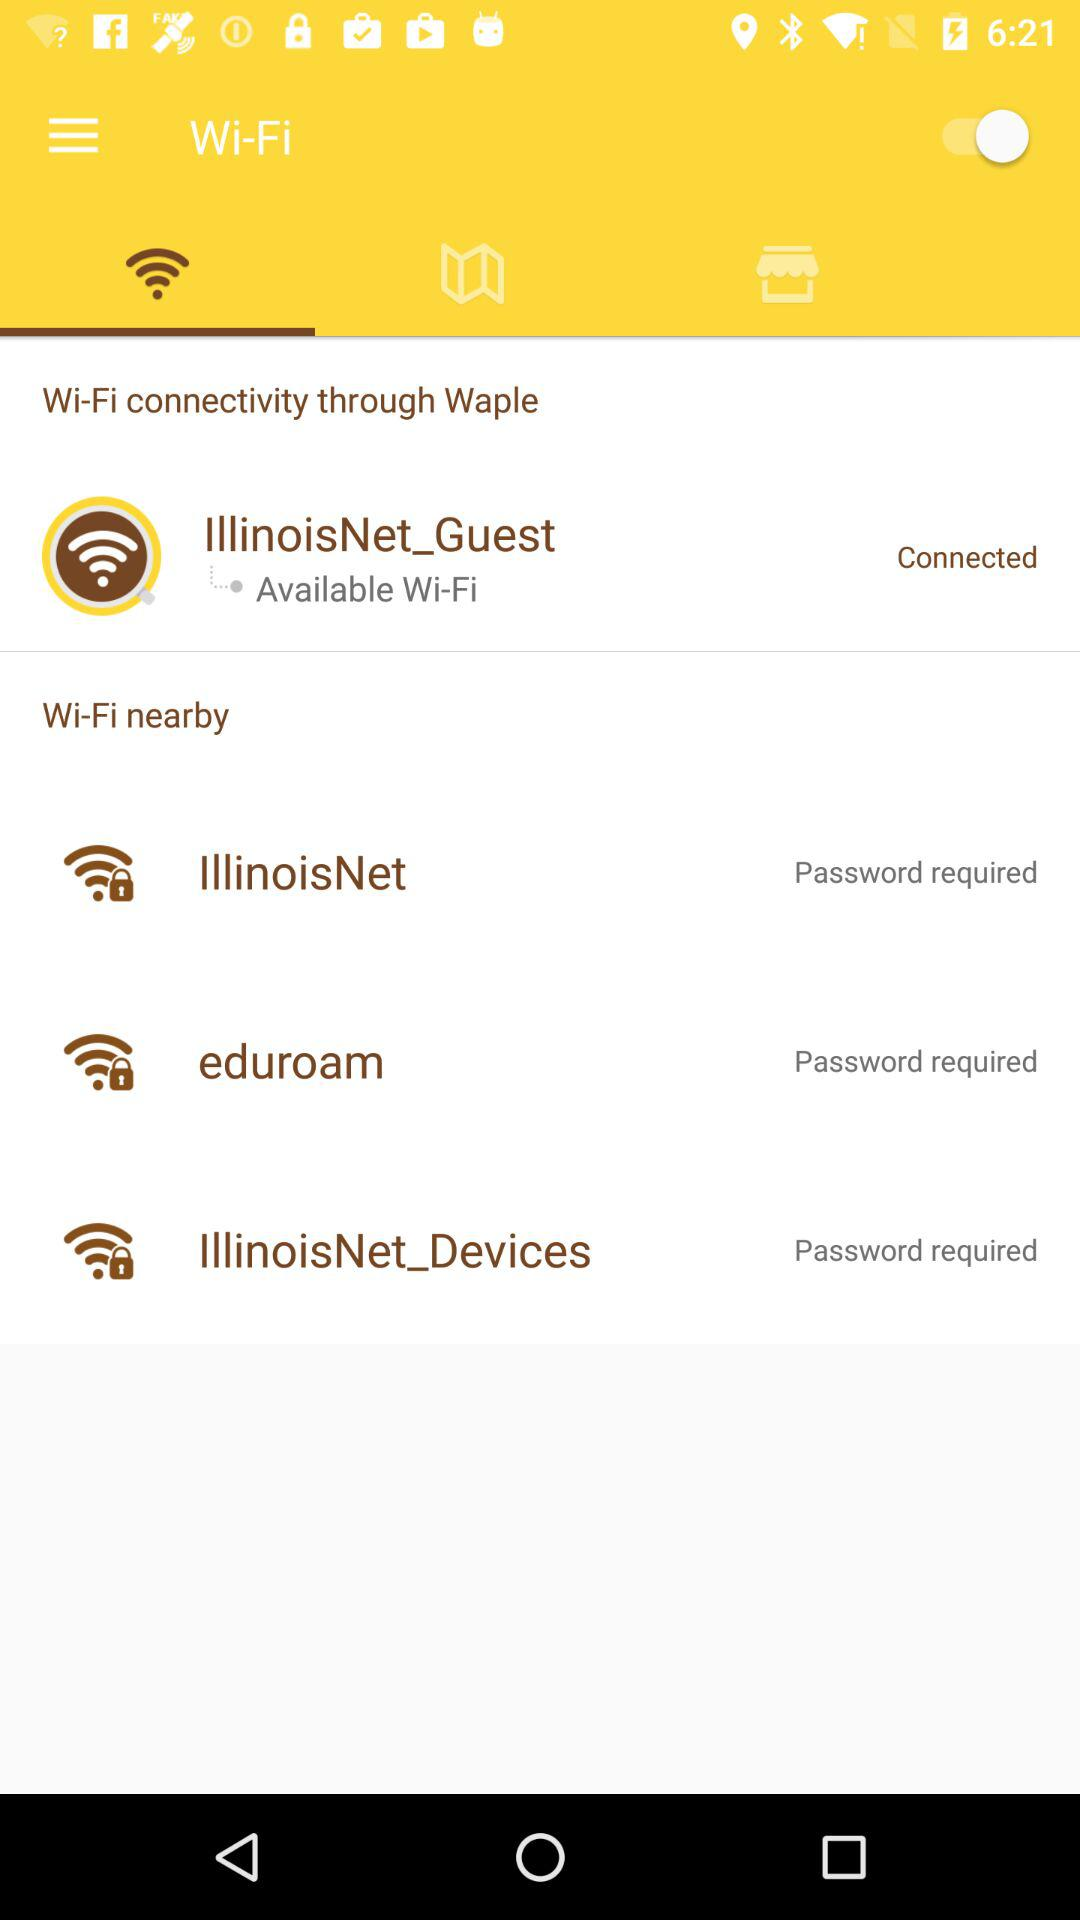How many Wi-Fi networks are available?
Answer the question using a single word or phrase. 3 